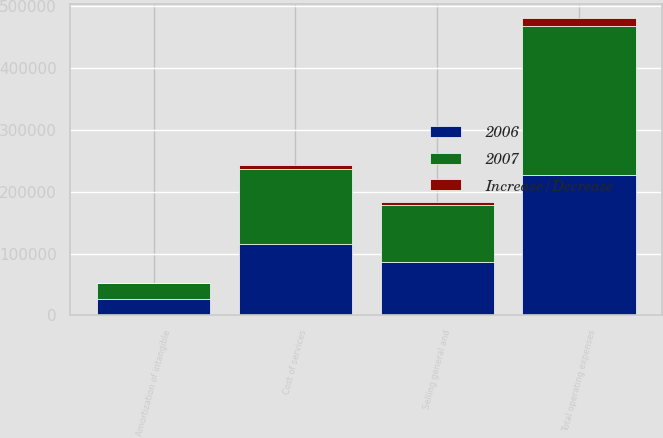<chart> <loc_0><loc_0><loc_500><loc_500><stacked_bar_chart><ecel><fcel>Cost of services<fcel>Selling general and<fcel>Amortization of intangible<fcel>Total operating expenses<nl><fcel>2007<fcel>121752<fcel>91822<fcel>26353<fcel>239927<nl><fcel>2006<fcel>115068<fcel>86425<fcel>26156<fcel>227649<nl><fcel>Increase/Decrease<fcel>6684<fcel>5397<fcel>197<fcel>12278<nl></chart> 